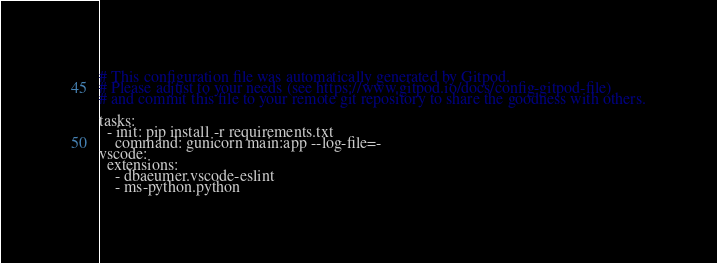<code> <loc_0><loc_0><loc_500><loc_500><_YAML_># This configuration file was automatically generated by Gitpod.
# Please adjust to your needs (see https://www.gitpod.io/docs/config-gitpod-file)
# and commit this file to your remote git repository to share the goodness with others.

tasks:
  - init: pip install -r requirements.txt
    command: gunicorn main:app --log-file=-
vscode:
  extensions:
    - dbaeumer.vscode-eslint
    - ms-python.python

</code> 